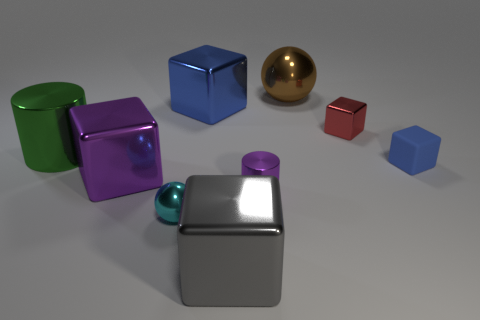Subtract all blue metallic cubes. How many cubes are left? 4 Add 1 large cylinders. How many objects exist? 10 Subtract all cylinders. How many objects are left? 7 Subtract all small purple objects. Subtract all big gray metallic things. How many objects are left? 7 Add 9 small red metal things. How many small red metal things are left? 10 Add 1 rubber things. How many rubber things exist? 2 Subtract all purple cubes. How many cubes are left? 4 Subtract 0 purple balls. How many objects are left? 9 Subtract 4 blocks. How many blocks are left? 1 Subtract all red balls. Subtract all brown cylinders. How many balls are left? 2 